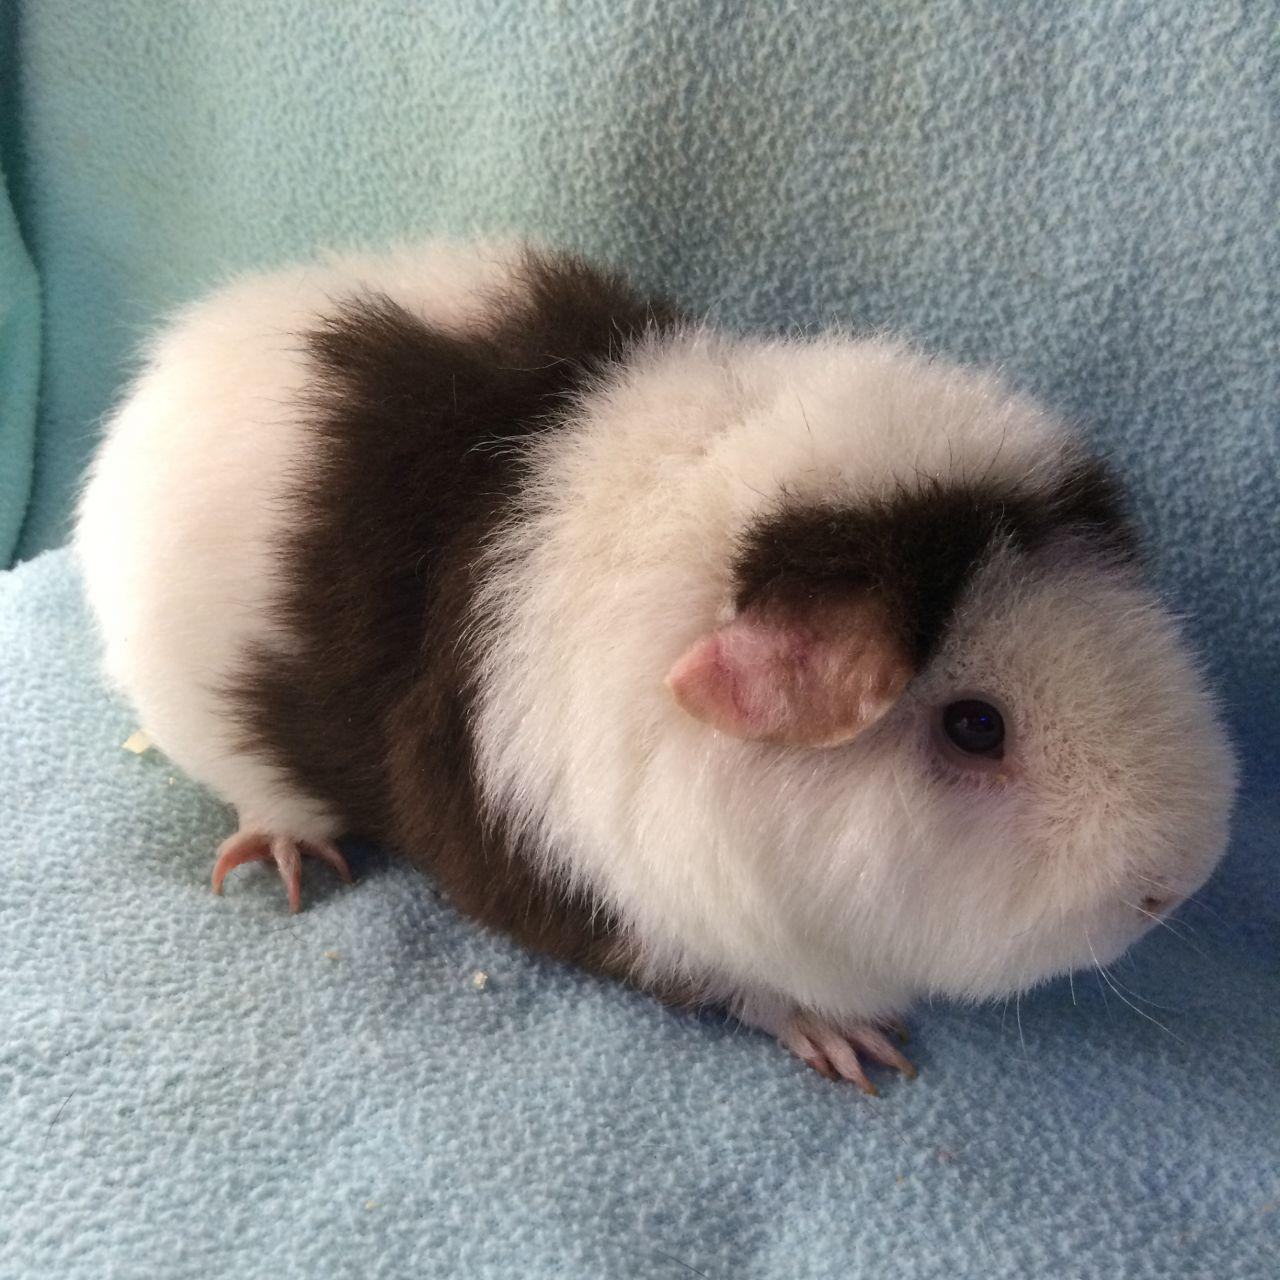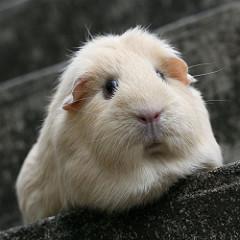The first image is the image on the left, the second image is the image on the right. Examine the images to the left and right. Is the description "The left image contains a row of three guinea pigs, and the right image contains two guinea pigs with wavy fur." accurate? Answer yes or no. No. The first image is the image on the left, the second image is the image on the right. Evaluate the accuracy of this statement regarding the images: "The right image contains exactly two rodents.". Is it true? Answer yes or no. No. 